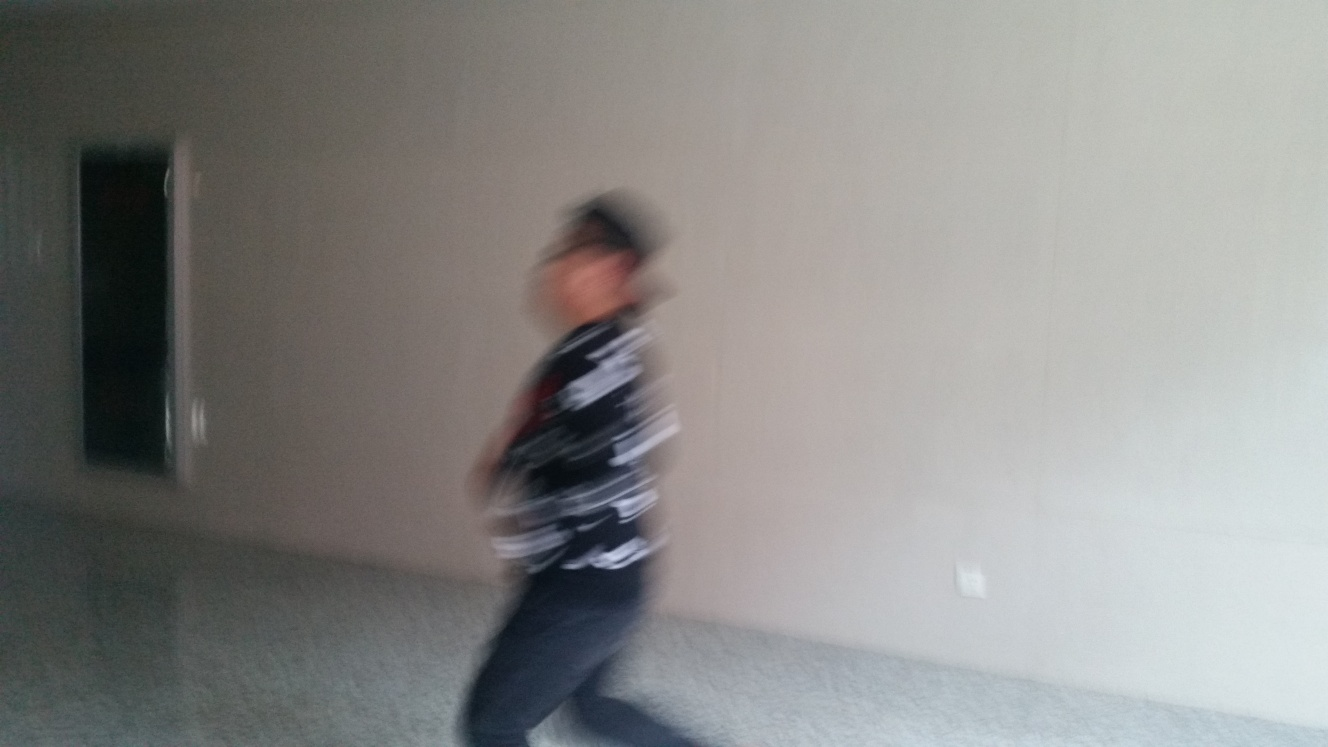What is happening in this scene? It appears to be an indoor setting with a person moving quickly, causing a blur effect in the photograph. The setting seems to be relatively plain with neutral tones, and the motion suggests an action or haste. Is there anything of note in the surroundings? The surroundings are quite bare with minimal furniture or decor visible, indicating an unfurnished room or space that might be in the process of being set up or cleared out. 